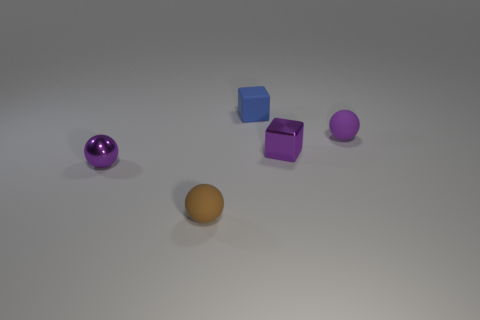Subtract 1 spheres. How many spheres are left? 2 Subtract all brown rubber balls. How many balls are left? 2 Subtract all purple spheres. How many spheres are left? 1 Subtract all yellow balls. Subtract all brown cylinders. How many balls are left? 3 Subtract all brown cylinders. Subtract all brown objects. How many objects are left? 4 Add 3 cubes. How many cubes are left? 5 Add 3 small blue objects. How many small blue objects exist? 4 Add 5 tiny yellow things. How many objects exist? 10 Subtract 1 brown spheres. How many objects are left? 4 Subtract all blocks. How many objects are left? 3 